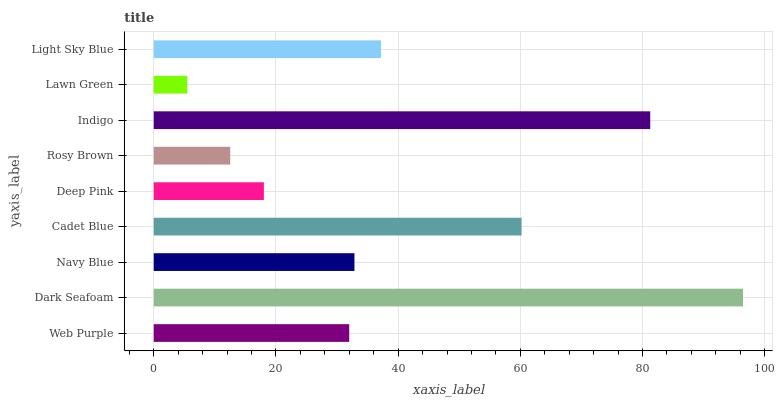Is Lawn Green the minimum?
Answer yes or no. Yes. Is Dark Seafoam the maximum?
Answer yes or no. Yes. Is Navy Blue the minimum?
Answer yes or no. No. Is Navy Blue the maximum?
Answer yes or no. No. Is Dark Seafoam greater than Navy Blue?
Answer yes or no. Yes. Is Navy Blue less than Dark Seafoam?
Answer yes or no. Yes. Is Navy Blue greater than Dark Seafoam?
Answer yes or no. No. Is Dark Seafoam less than Navy Blue?
Answer yes or no. No. Is Navy Blue the high median?
Answer yes or no. Yes. Is Navy Blue the low median?
Answer yes or no. Yes. Is Indigo the high median?
Answer yes or no. No. Is Deep Pink the low median?
Answer yes or no. No. 